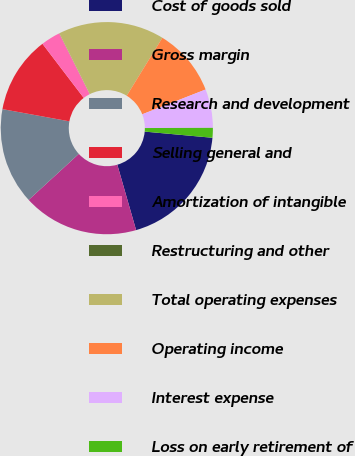<chart> <loc_0><loc_0><loc_500><loc_500><pie_chart><fcel>Cost of goods sold<fcel>Gross margin<fcel>Research and development<fcel>Selling general and<fcel>Amortization of intangible<fcel>Restructuring and other<fcel>Total operating expenses<fcel>Operating income<fcel>Interest expense<fcel>Loss on early retirement of<nl><fcel>19.1%<fcel>17.63%<fcel>14.69%<fcel>11.76%<fcel>2.96%<fcel>0.02%<fcel>16.16%<fcel>10.29%<fcel>5.89%<fcel>1.49%<nl></chart> 